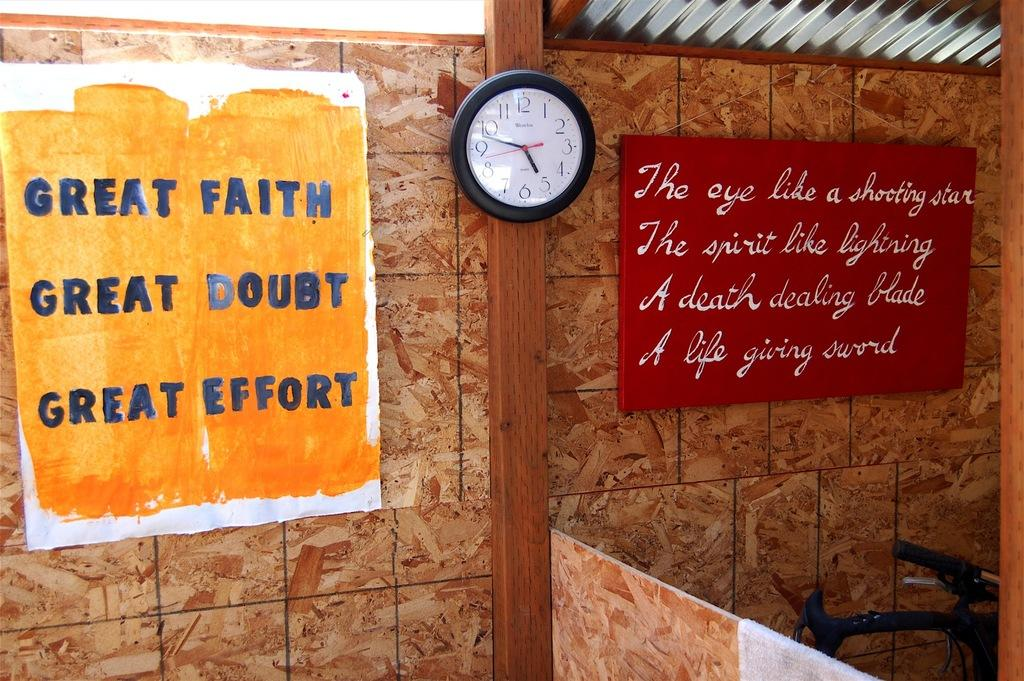<image>
Write a terse but informative summary of the picture. White and yellow sign which says "Great Faith" on the top. 